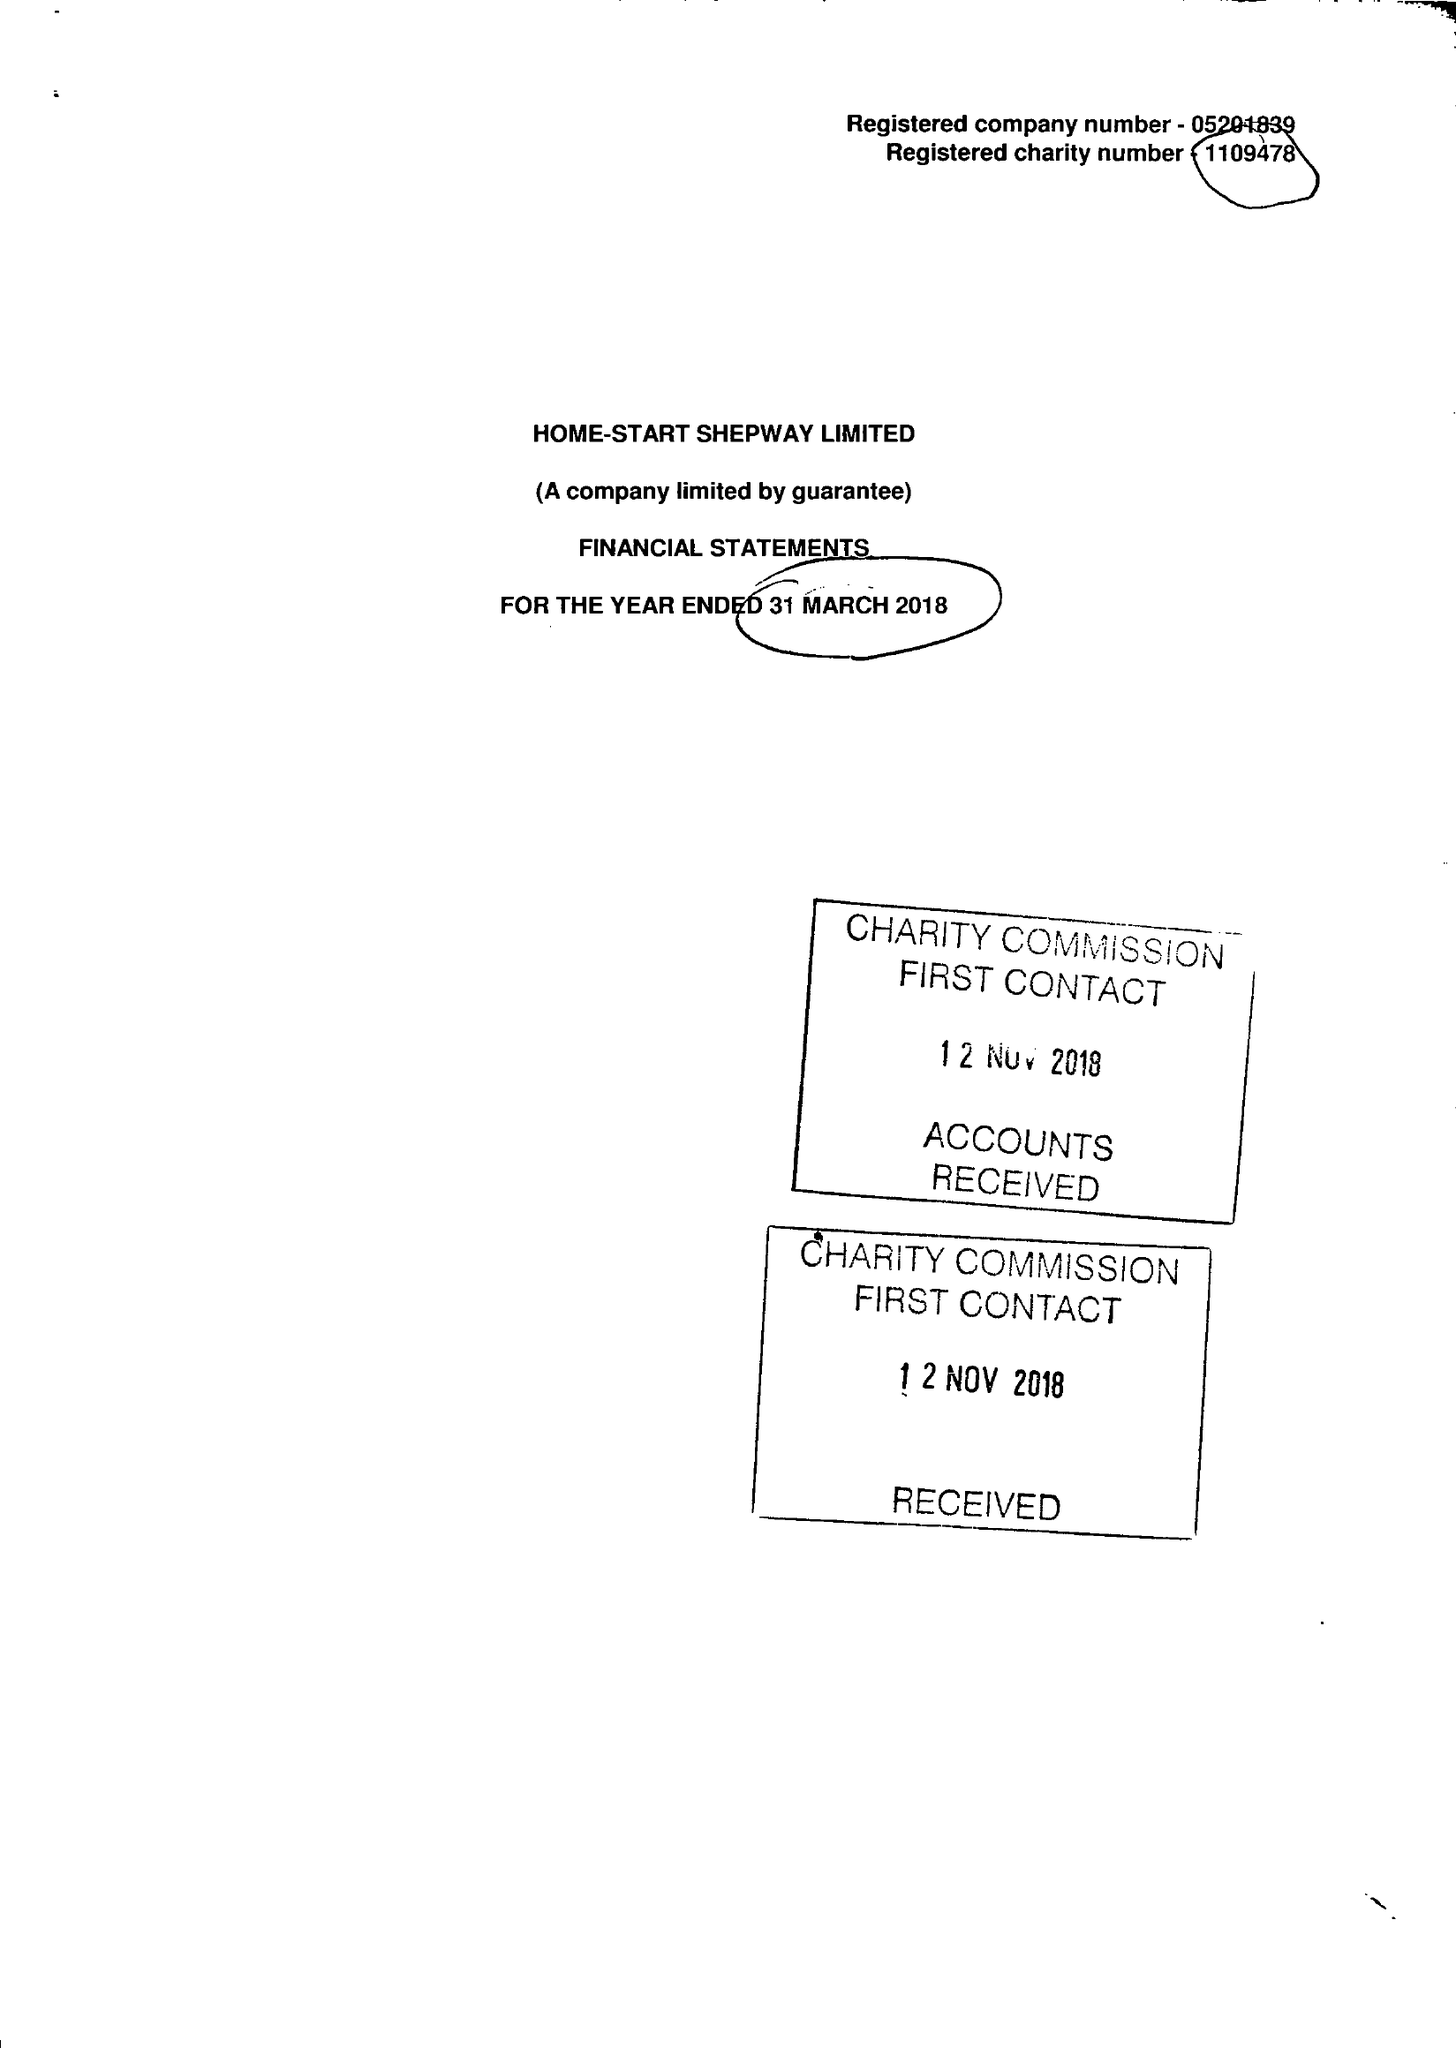What is the value for the address__postcode?
Answer the question using a single word or phrase. CT20 2AS 